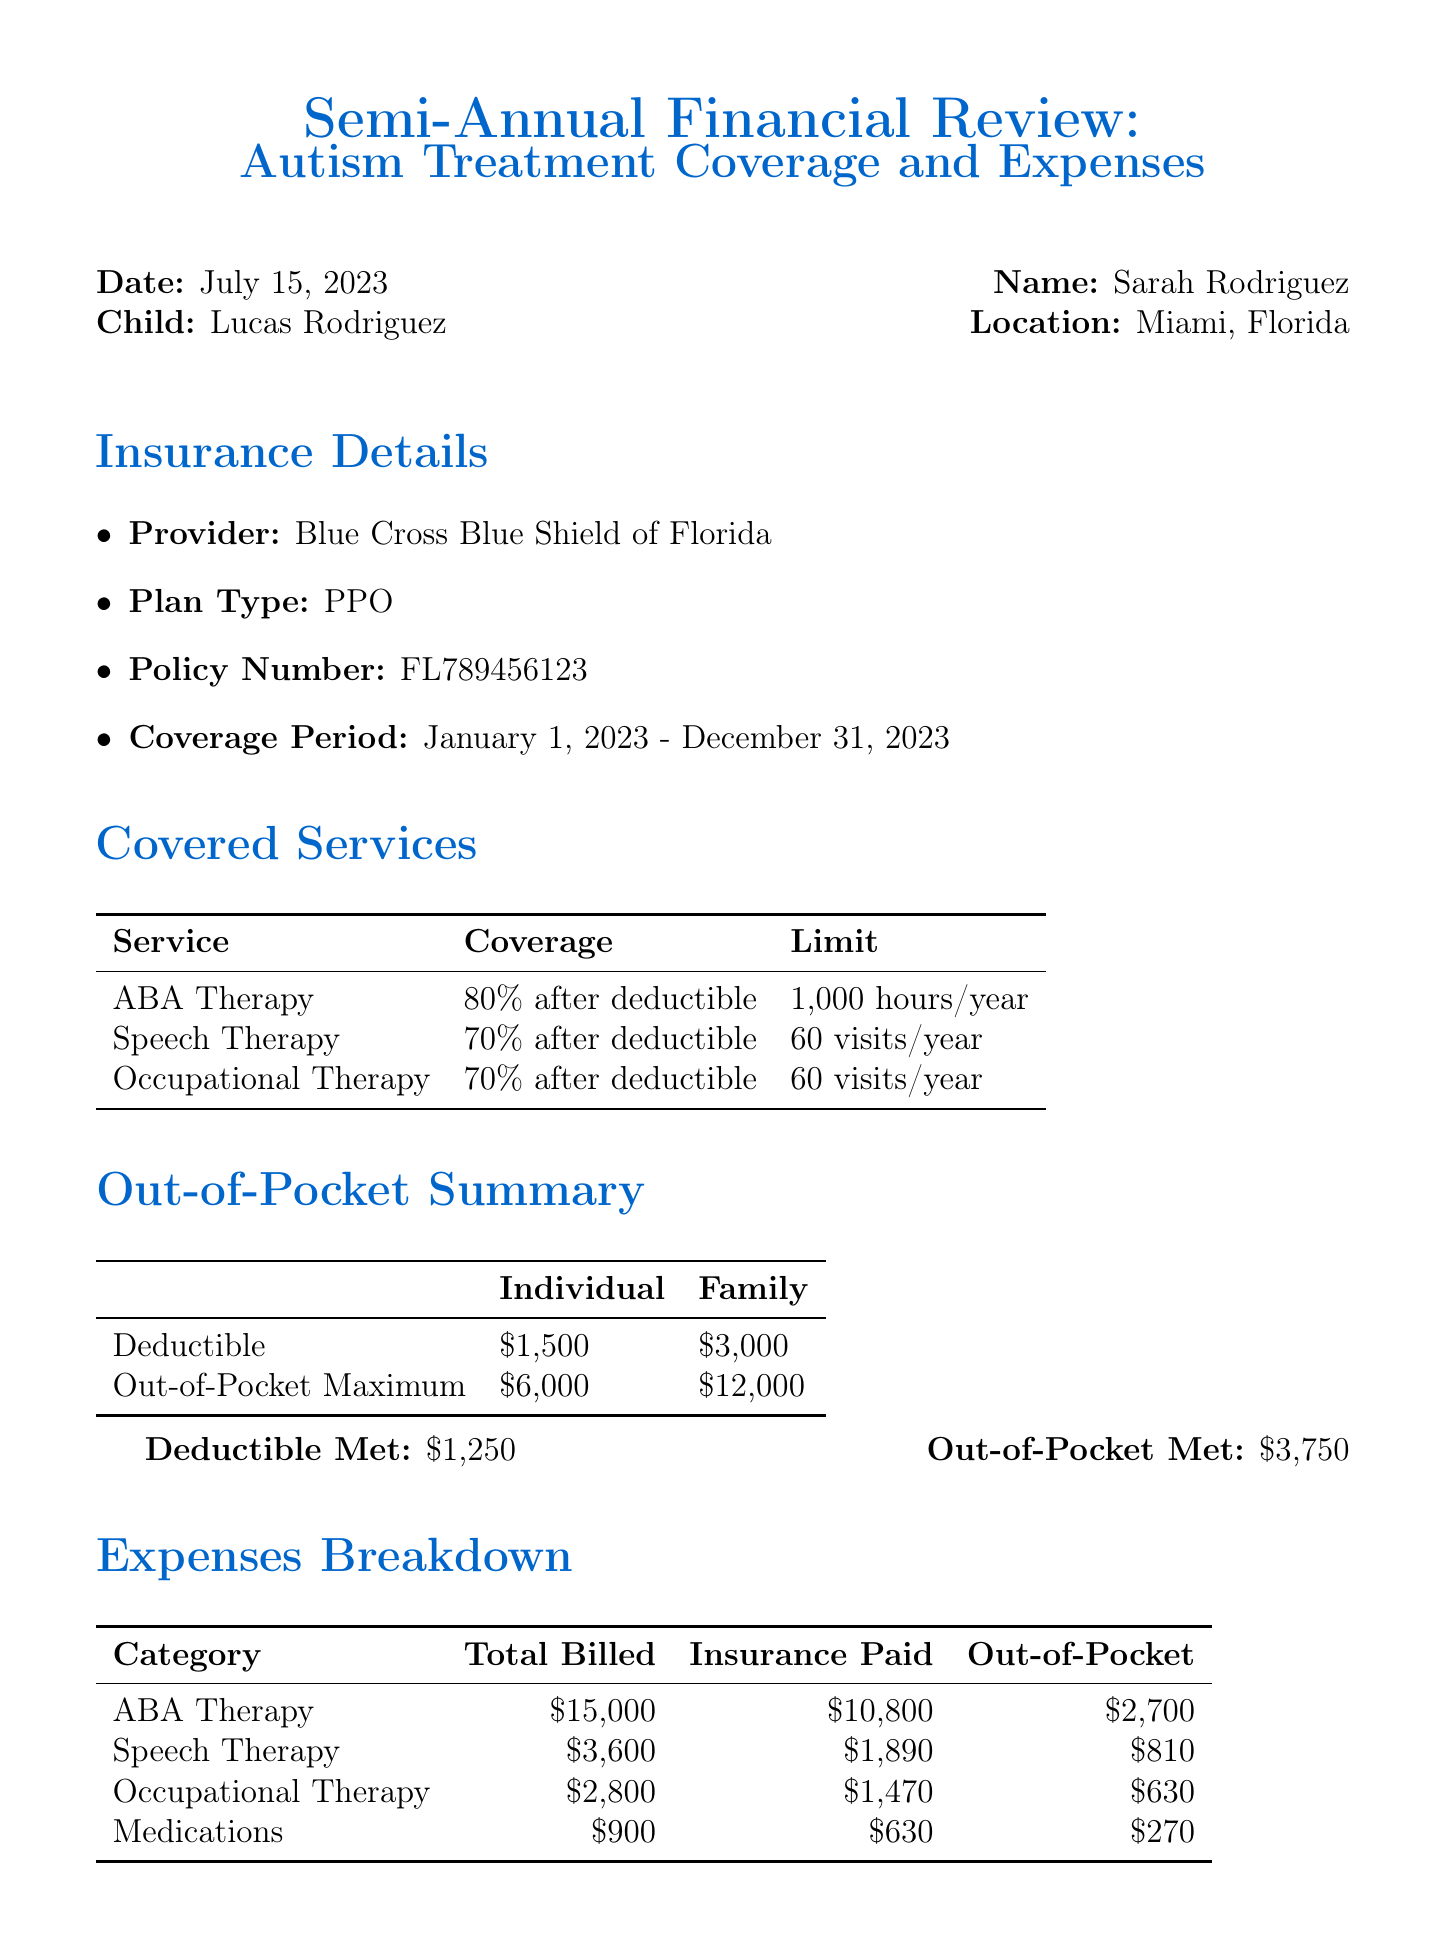what is the provider of the insurance? The provider of the insurance is listed in the insurance details section of the document.
Answer: Blue Cross Blue Shield of Florida what is the coverage for Applied Behavior Analysis (ABA) Therapy? The coverage is specified in the covered services section where the services and their details are listed.
Answer: 80% after deductible how many hours of ABA Therapy are covered per year? The limit for hours of ABA Therapy is provided in the covered services section of the document.
Answer: 1,000 hours per year what is the individual deductible amount? The individual deductible is stated in the out-of-pocket summary of the document.
Answer: $1,500 how much out-of-pocket was spent on Speech Therapy? The out-of-pocket expense for Speech Therapy is detailed in the expenses breakdown section.
Answer: $810 what is the total billed for Occupational Therapy? The total billed for Occupational Therapy can be found in the expenses breakdown section.
Answer: $2,800 how much has been met for the out-of-pocket maximum? The amount met for the out-of-pocket maximum is mentioned in the out-of-pocket summary section of the document.
Answer: $3,750 what is the total amount of insurance paid for ABA Therapy? The insurance paid amount for ABA Therapy is specified in the expenses breakdown section.
Answer: $10,800 name a local resource mentioned in the document. The document lists local resources that are available for autism-related support.
Answer: University of Miami-Nova Southeastern University Center for Autism & Related Disabilities (UM-NSU CARD) 